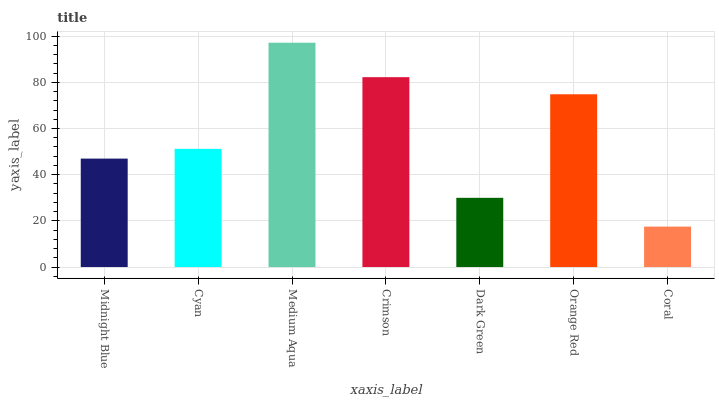Is Cyan the minimum?
Answer yes or no. No. Is Cyan the maximum?
Answer yes or no. No. Is Cyan greater than Midnight Blue?
Answer yes or no. Yes. Is Midnight Blue less than Cyan?
Answer yes or no. Yes. Is Midnight Blue greater than Cyan?
Answer yes or no. No. Is Cyan less than Midnight Blue?
Answer yes or no. No. Is Cyan the high median?
Answer yes or no. Yes. Is Cyan the low median?
Answer yes or no. Yes. Is Crimson the high median?
Answer yes or no. No. Is Coral the low median?
Answer yes or no. No. 